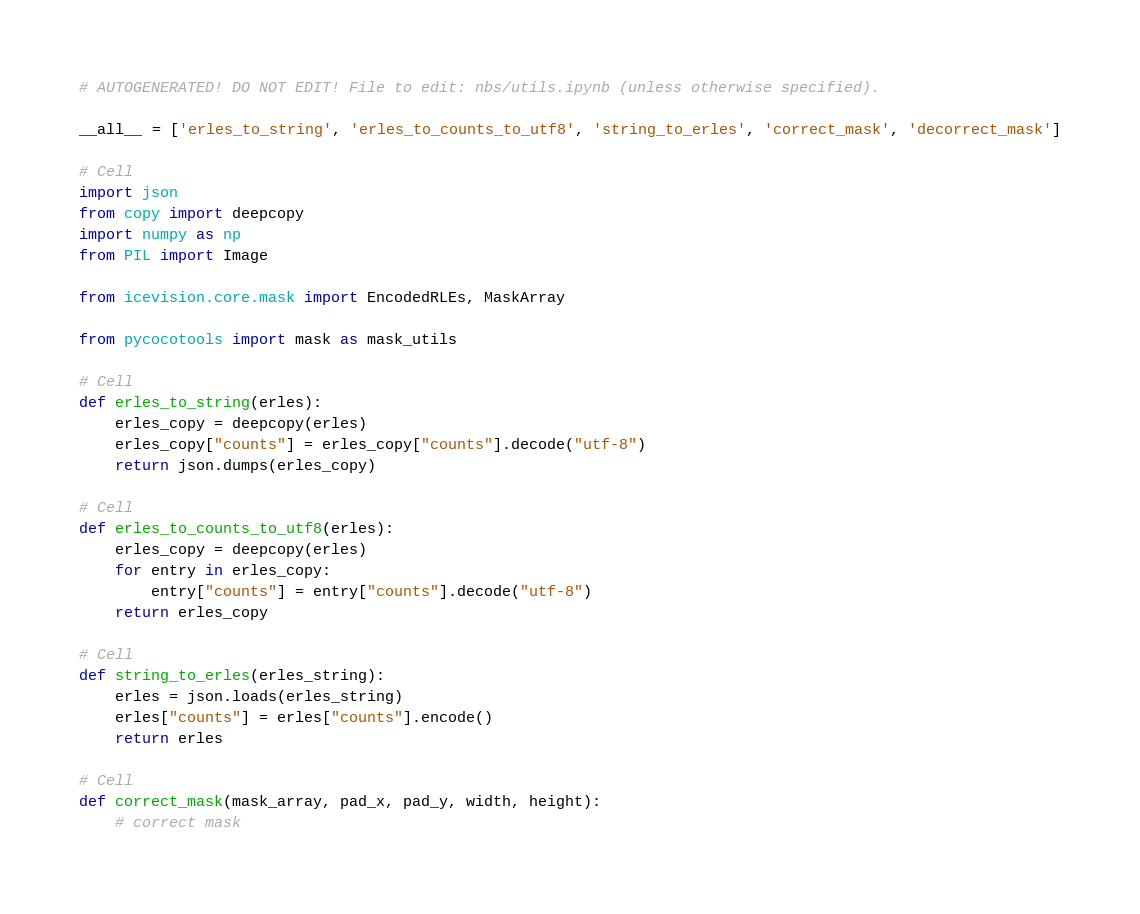<code> <loc_0><loc_0><loc_500><loc_500><_Python_># AUTOGENERATED! DO NOT EDIT! File to edit: nbs/utils.ipynb (unless otherwise specified).

__all__ = ['erles_to_string', 'erles_to_counts_to_utf8', 'string_to_erles', 'correct_mask', 'decorrect_mask']

# Cell
import json
from copy import deepcopy
import numpy as np
from PIL import Image

from icevision.core.mask import EncodedRLEs, MaskArray

from pycocotools import mask as mask_utils

# Cell
def erles_to_string(erles):
    erles_copy = deepcopy(erles)
    erles_copy["counts"] = erles_copy["counts"].decode("utf-8")
    return json.dumps(erles_copy)

# Cell
def erles_to_counts_to_utf8(erles):
    erles_copy = deepcopy(erles)
    for entry in erles_copy:
        entry["counts"] = entry["counts"].decode("utf-8")
    return erles_copy

# Cell
def string_to_erles(erles_string):
    erles = json.loads(erles_string)
    erles["counts"] = erles["counts"].encode()
    return erles

# Cell
def correct_mask(mask_array, pad_x, pad_y, width, height):
    # correct mask</code> 